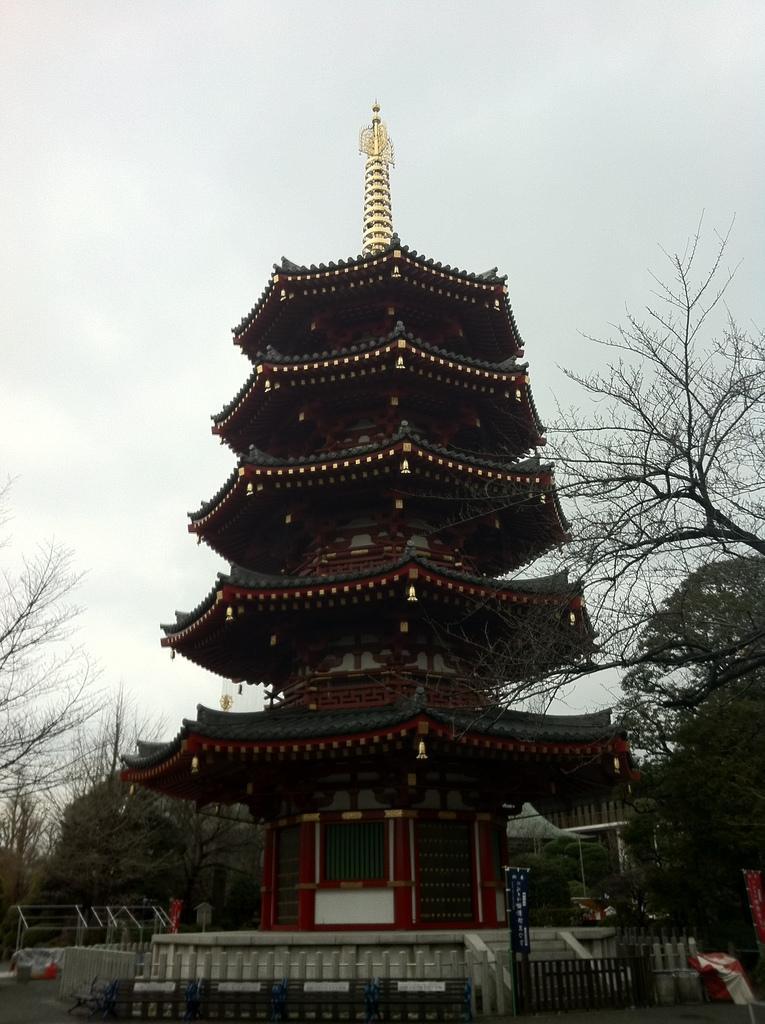Could you give a brief overview of what you see in this image? In this image we can see a building. Also there are railings. Near to the building there are trees. In the background there is sky. 